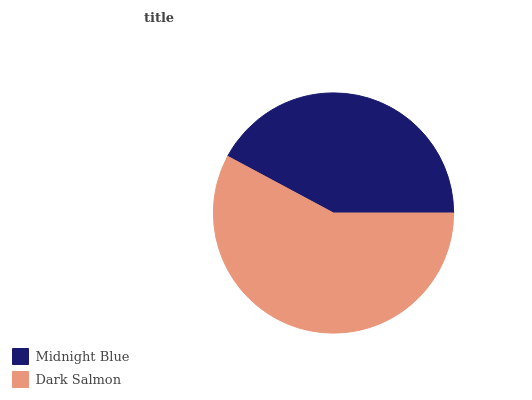Is Midnight Blue the minimum?
Answer yes or no. Yes. Is Dark Salmon the maximum?
Answer yes or no. Yes. Is Dark Salmon the minimum?
Answer yes or no. No. Is Dark Salmon greater than Midnight Blue?
Answer yes or no. Yes. Is Midnight Blue less than Dark Salmon?
Answer yes or no. Yes. Is Midnight Blue greater than Dark Salmon?
Answer yes or no. No. Is Dark Salmon less than Midnight Blue?
Answer yes or no. No. Is Dark Salmon the high median?
Answer yes or no. Yes. Is Midnight Blue the low median?
Answer yes or no. Yes. Is Midnight Blue the high median?
Answer yes or no. No. Is Dark Salmon the low median?
Answer yes or no. No. 